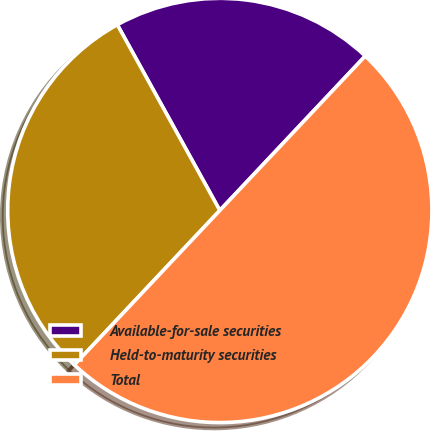Convert chart to OTSL. <chart><loc_0><loc_0><loc_500><loc_500><pie_chart><fcel>Available-for-sale securities<fcel>Held-to-maturity securities<fcel>Total<nl><fcel>20.05%<fcel>29.95%<fcel>50.0%<nl></chart> 